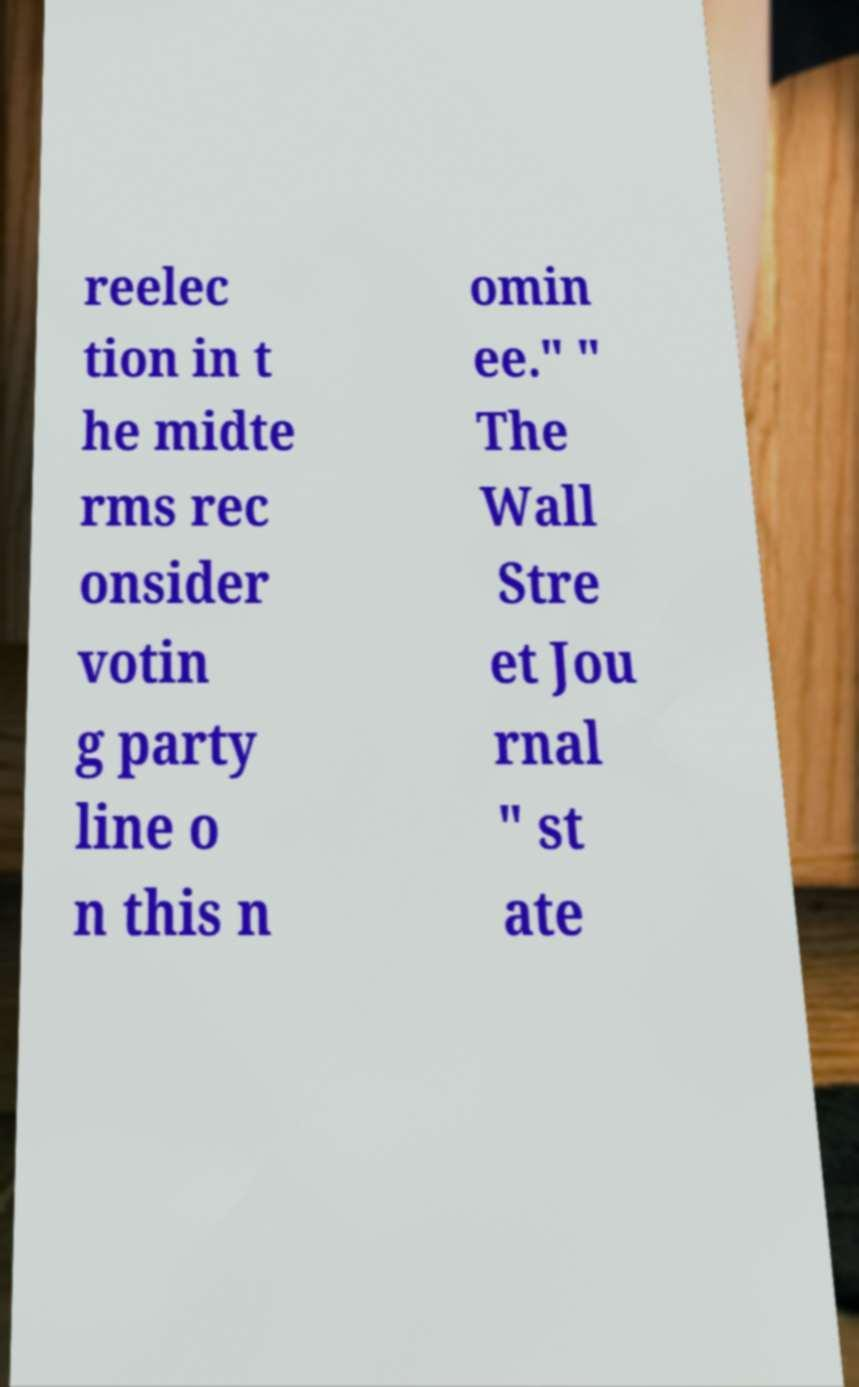Please read and relay the text visible in this image. What does it say? reelec tion in t he midte rms rec onsider votin g party line o n this n omin ee." " The Wall Stre et Jou rnal " st ate 